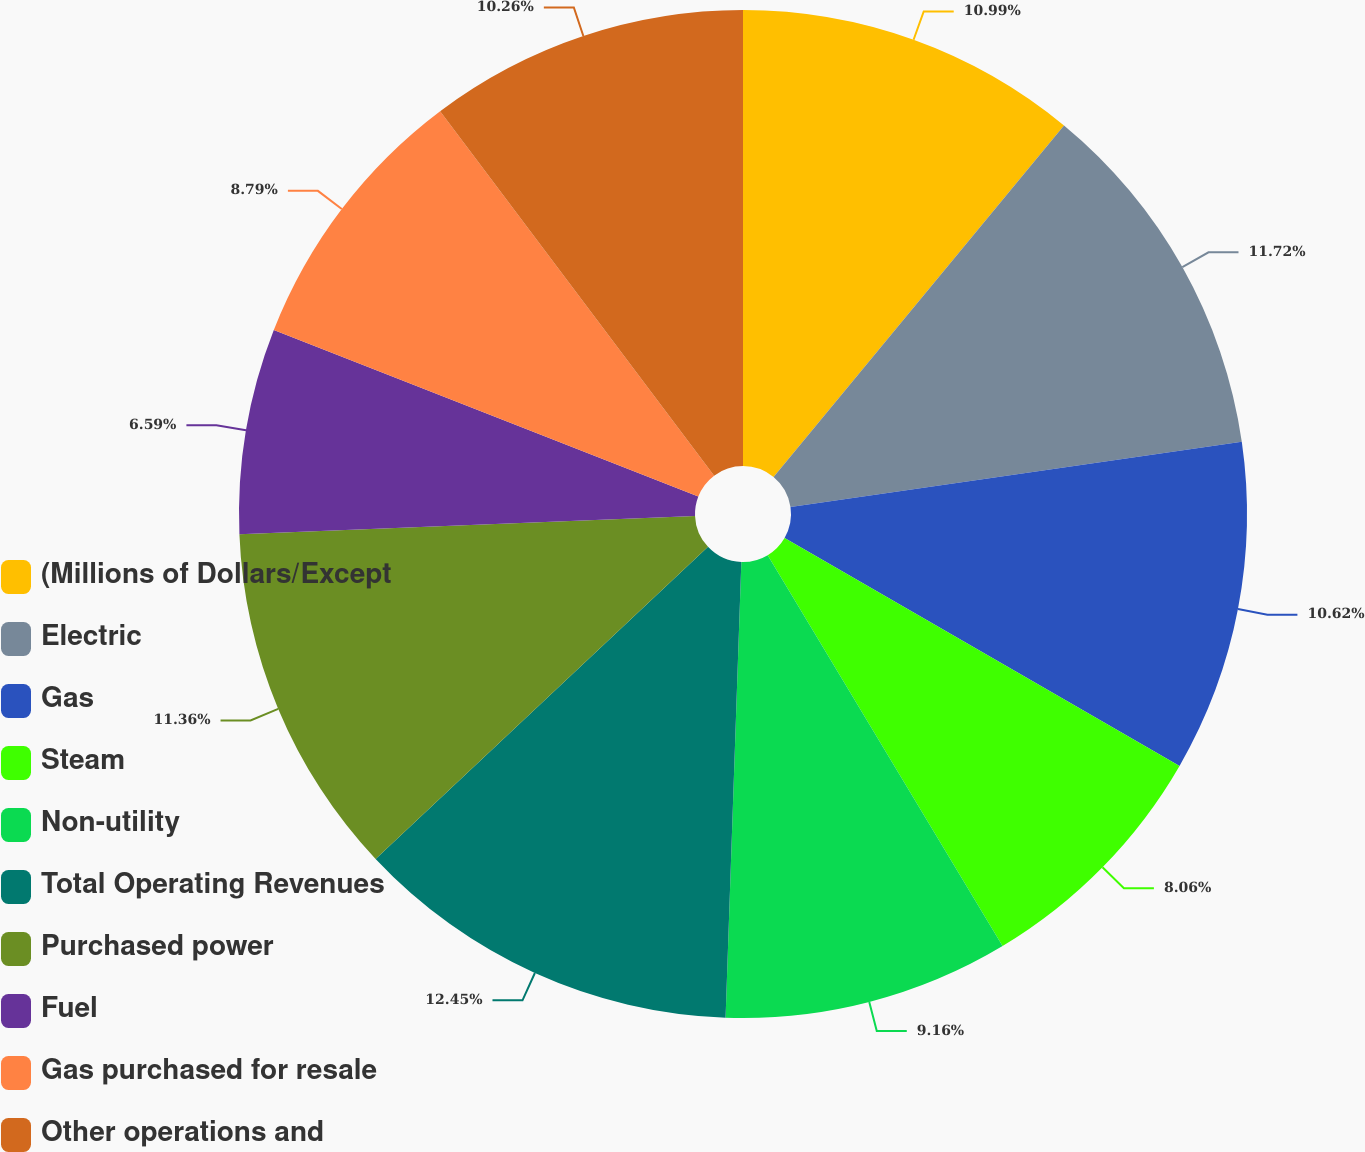Convert chart to OTSL. <chart><loc_0><loc_0><loc_500><loc_500><pie_chart><fcel>(Millions of Dollars/Except<fcel>Electric<fcel>Gas<fcel>Steam<fcel>Non-utility<fcel>Total Operating Revenues<fcel>Purchased power<fcel>Fuel<fcel>Gas purchased for resale<fcel>Other operations and<nl><fcel>10.99%<fcel>11.72%<fcel>10.62%<fcel>8.06%<fcel>9.16%<fcel>12.45%<fcel>11.36%<fcel>6.59%<fcel>8.79%<fcel>10.26%<nl></chart> 